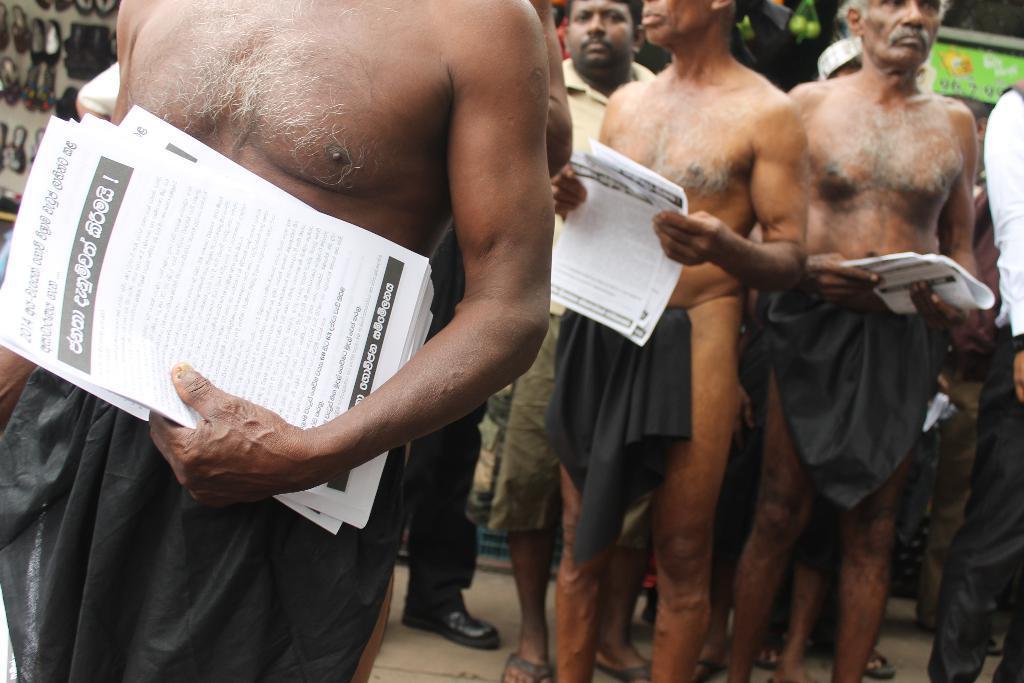Can you describe this image briefly? In this image I can see men standing, holding papers. There are footwear on the left. 